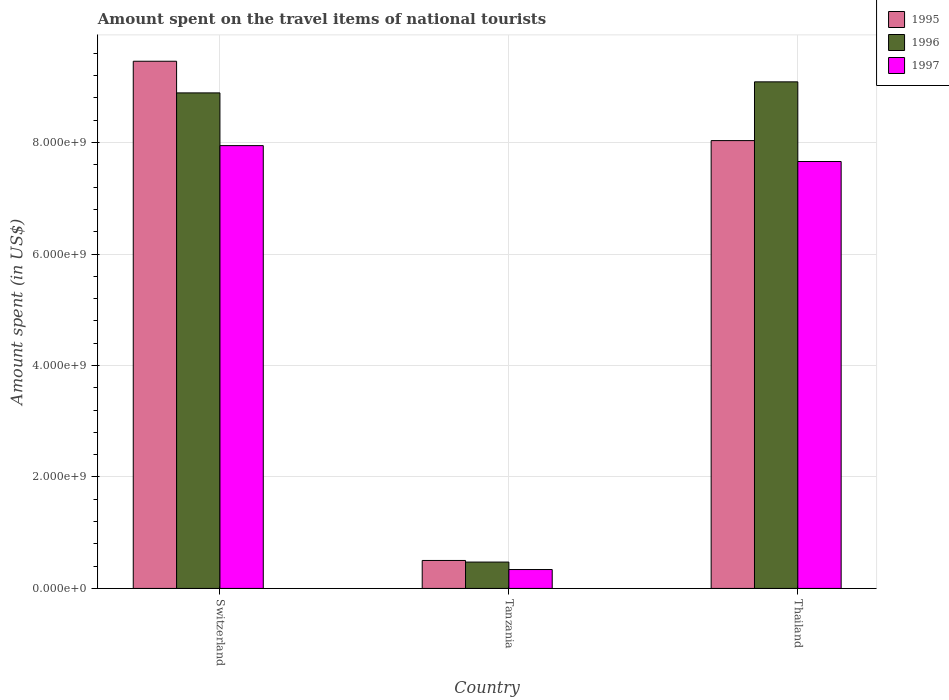How many bars are there on the 1st tick from the right?
Your response must be concise. 3. What is the label of the 3rd group of bars from the left?
Give a very brief answer. Thailand. In how many cases, is the number of bars for a given country not equal to the number of legend labels?
Provide a succinct answer. 0. What is the amount spent on the travel items of national tourists in 1995 in Tanzania?
Ensure brevity in your answer.  5.02e+08. Across all countries, what is the maximum amount spent on the travel items of national tourists in 1997?
Your response must be concise. 7.94e+09. Across all countries, what is the minimum amount spent on the travel items of national tourists in 1997?
Your answer should be compact. 3.39e+08. In which country was the amount spent on the travel items of national tourists in 1996 maximum?
Provide a succinct answer. Thailand. In which country was the amount spent on the travel items of national tourists in 1995 minimum?
Ensure brevity in your answer.  Tanzania. What is the total amount spent on the travel items of national tourists in 1996 in the graph?
Your answer should be very brief. 1.85e+1. What is the difference between the amount spent on the travel items of national tourists in 1997 in Tanzania and that in Thailand?
Your response must be concise. -7.32e+09. What is the difference between the amount spent on the travel items of national tourists in 1997 in Thailand and the amount spent on the travel items of national tourists in 1996 in Switzerland?
Provide a short and direct response. -1.23e+09. What is the average amount spent on the travel items of national tourists in 1997 per country?
Your response must be concise. 5.31e+09. What is the difference between the amount spent on the travel items of national tourists of/in 1996 and amount spent on the travel items of national tourists of/in 1997 in Tanzania?
Provide a short and direct response. 1.34e+08. What is the ratio of the amount spent on the travel items of national tourists in 1996 in Switzerland to that in Thailand?
Provide a short and direct response. 0.98. Is the amount spent on the travel items of national tourists in 1997 in Switzerland less than that in Tanzania?
Provide a succinct answer. No. What is the difference between the highest and the second highest amount spent on the travel items of national tourists in 1995?
Offer a terse response. 8.96e+09. What is the difference between the highest and the lowest amount spent on the travel items of national tourists in 1997?
Your response must be concise. 7.61e+09. In how many countries, is the amount spent on the travel items of national tourists in 1996 greater than the average amount spent on the travel items of national tourists in 1996 taken over all countries?
Provide a succinct answer. 2. What does the 3rd bar from the left in Tanzania represents?
Provide a short and direct response. 1997. What does the 2nd bar from the right in Thailand represents?
Your answer should be very brief. 1996. Is it the case that in every country, the sum of the amount spent on the travel items of national tourists in 1995 and amount spent on the travel items of national tourists in 1997 is greater than the amount spent on the travel items of national tourists in 1996?
Make the answer very short. Yes. How many bars are there?
Provide a short and direct response. 9. Are the values on the major ticks of Y-axis written in scientific E-notation?
Give a very brief answer. Yes. Does the graph contain grids?
Ensure brevity in your answer.  Yes. How many legend labels are there?
Provide a short and direct response. 3. What is the title of the graph?
Your answer should be very brief. Amount spent on the travel items of national tourists. What is the label or title of the X-axis?
Your response must be concise. Country. What is the label or title of the Y-axis?
Keep it short and to the point. Amount spent (in US$). What is the Amount spent (in US$) in 1995 in Switzerland?
Make the answer very short. 9.46e+09. What is the Amount spent (in US$) in 1996 in Switzerland?
Ensure brevity in your answer.  8.89e+09. What is the Amount spent (in US$) in 1997 in Switzerland?
Offer a very short reply. 7.94e+09. What is the Amount spent (in US$) in 1995 in Tanzania?
Give a very brief answer. 5.02e+08. What is the Amount spent (in US$) in 1996 in Tanzania?
Give a very brief answer. 4.73e+08. What is the Amount spent (in US$) of 1997 in Tanzania?
Ensure brevity in your answer.  3.39e+08. What is the Amount spent (in US$) in 1995 in Thailand?
Your answer should be compact. 8.04e+09. What is the Amount spent (in US$) of 1996 in Thailand?
Provide a succinct answer. 9.09e+09. What is the Amount spent (in US$) in 1997 in Thailand?
Ensure brevity in your answer.  7.66e+09. Across all countries, what is the maximum Amount spent (in US$) of 1995?
Offer a very short reply. 9.46e+09. Across all countries, what is the maximum Amount spent (in US$) in 1996?
Give a very brief answer. 9.09e+09. Across all countries, what is the maximum Amount spent (in US$) in 1997?
Make the answer very short. 7.94e+09. Across all countries, what is the minimum Amount spent (in US$) of 1995?
Your answer should be compact. 5.02e+08. Across all countries, what is the minimum Amount spent (in US$) of 1996?
Offer a terse response. 4.73e+08. Across all countries, what is the minimum Amount spent (in US$) of 1997?
Provide a succinct answer. 3.39e+08. What is the total Amount spent (in US$) in 1995 in the graph?
Your answer should be very brief. 1.80e+1. What is the total Amount spent (in US$) in 1996 in the graph?
Provide a short and direct response. 1.85e+1. What is the total Amount spent (in US$) in 1997 in the graph?
Make the answer very short. 1.59e+1. What is the difference between the Amount spent (in US$) in 1995 in Switzerland and that in Tanzania?
Provide a short and direct response. 8.96e+09. What is the difference between the Amount spent (in US$) of 1996 in Switzerland and that in Tanzania?
Provide a short and direct response. 8.42e+09. What is the difference between the Amount spent (in US$) in 1997 in Switzerland and that in Tanzania?
Give a very brief answer. 7.61e+09. What is the difference between the Amount spent (in US$) of 1995 in Switzerland and that in Thailand?
Your answer should be compact. 1.42e+09. What is the difference between the Amount spent (in US$) of 1996 in Switzerland and that in Thailand?
Offer a terse response. -1.98e+08. What is the difference between the Amount spent (in US$) of 1997 in Switzerland and that in Thailand?
Your answer should be very brief. 2.85e+08. What is the difference between the Amount spent (in US$) of 1995 in Tanzania and that in Thailand?
Offer a very short reply. -7.53e+09. What is the difference between the Amount spent (in US$) in 1996 in Tanzania and that in Thailand?
Make the answer very short. -8.62e+09. What is the difference between the Amount spent (in US$) of 1997 in Tanzania and that in Thailand?
Ensure brevity in your answer.  -7.32e+09. What is the difference between the Amount spent (in US$) of 1995 in Switzerland and the Amount spent (in US$) of 1996 in Tanzania?
Offer a terse response. 8.99e+09. What is the difference between the Amount spent (in US$) of 1995 in Switzerland and the Amount spent (in US$) of 1997 in Tanzania?
Provide a succinct answer. 9.12e+09. What is the difference between the Amount spent (in US$) in 1996 in Switzerland and the Amount spent (in US$) in 1997 in Tanzania?
Your answer should be very brief. 8.55e+09. What is the difference between the Amount spent (in US$) of 1995 in Switzerland and the Amount spent (in US$) of 1996 in Thailand?
Your answer should be very brief. 3.70e+08. What is the difference between the Amount spent (in US$) in 1995 in Switzerland and the Amount spent (in US$) in 1997 in Thailand?
Offer a very short reply. 1.80e+09. What is the difference between the Amount spent (in US$) in 1996 in Switzerland and the Amount spent (in US$) in 1997 in Thailand?
Keep it short and to the point. 1.23e+09. What is the difference between the Amount spent (in US$) in 1995 in Tanzania and the Amount spent (in US$) in 1996 in Thailand?
Your response must be concise. -8.59e+09. What is the difference between the Amount spent (in US$) in 1995 in Tanzania and the Amount spent (in US$) in 1997 in Thailand?
Keep it short and to the point. -7.16e+09. What is the difference between the Amount spent (in US$) of 1996 in Tanzania and the Amount spent (in US$) of 1997 in Thailand?
Offer a very short reply. -7.19e+09. What is the average Amount spent (in US$) of 1995 per country?
Your answer should be very brief. 6.00e+09. What is the average Amount spent (in US$) in 1996 per country?
Give a very brief answer. 6.15e+09. What is the average Amount spent (in US$) in 1997 per country?
Offer a terse response. 5.31e+09. What is the difference between the Amount spent (in US$) of 1995 and Amount spent (in US$) of 1996 in Switzerland?
Make the answer very short. 5.68e+08. What is the difference between the Amount spent (in US$) in 1995 and Amount spent (in US$) in 1997 in Switzerland?
Ensure brevity in your answer.  1.51e+09. What is the difference between the Amount spent (in US$) of 1996 and Amount spent (in US$) of 1997 in Switzerland?
Make the answer very short. 9.46e+08. What is the difference between the Amount spent (in US$) of 1995 and Amount spent (in US$) of 1996 in Tanzania?
Your answer should be very brief. 2.90e+07. What is the difference between the Amount spent (in US$) of 1995 and Amount spent (in US$) of 1997 in Tanzania?
Make the answer very short. 1.63e+08. What is the difference between the Amount spent (in US$) in 1996 and Amount spent (in US$) in 1997 in Tanzania?
Keep it short and to the point. 1.34e+08. What is the difference between the Amount spent (in US$) in 1995 and Amount spent (in US$) in 1996 in Thailand?
Offer a terse response. -1.05e+09. What is the difference between the Amount spent (in US$) of 1995 and Amount spent (in US$) of 1997 in Thailand?
Ensure brevity in your answer.  3.75e+08. What is the difference between the Amount spent (in US$) in 1996 and Amount spent (in US$) in 1997 in Thailand?
Provide a short and direct response. 1.43e+09. What is the ratio of the Amount spent (in US$) in 1995 in Switzerland to that in Tanzania?
Offer a terse response. 18.84. What is the ratio of the Amount spent (in US$) of 1996 in Switzerland to that in Tanzania?
Your answer should be very brief. 18.8. What is the ratio of the Amount spent (in US$) in 1997 in Switzerland to that in Tanzania?
Ensure brevity in your answer.  23.44. What is the ratio of the Amount spent (in US$) of 1995 in Switzerland to that in Thailand?
Your answer should be very brief. 1.18. What is the ratio of the Amount spent (in US$) of 1996 in Switzerland to that in Thailand?
Your response must be concise. 0.98. What is the ratio of the Amount spent (in US$) in 1997 in Switzerland to that in Thailand?
Give a very brief answer. 1.04. What is the ratio of the Amount spent (in US$) of 1995 in Tanzania to that in Thailand?
Keep it short and to the point. 0.06. What is the ratio of the Amount spent (in US$) of 1996 in Tanzania to that in Thailand?
Provide a short and direct response. 0.05. What is the ratio of the Amount spent (in US$) in 1997 in Tanzania to that in Thailand?
Your answer should be very brief. 0.04. What is the difference between the highest and the second highest Amount spent (in US$) in 1995?
Offer a very short reply. 1.42e+09. What is the difference between the highest and the second highest Amount spent (in US$) of 1996?
Give a very brief answer. 1.98e+08. What is the difference between the highest and the second highest Amount spent (in US$) in 1997?
Keep it short and to the point. 2.85e+08. What is the difference between the highest and the lowest Amount spent (in US$) of 1995?
Offer a terse response. 8.96e+09. What is the difference between the highest and the lowest Amount spent (in US$) in 1996?
Offer a very short reply. 8.62e+09. What is the difference between the highest and the lowest Amount spent (in US$) of 1997?
Ensure brevity in your answer.  7.61e+09. 